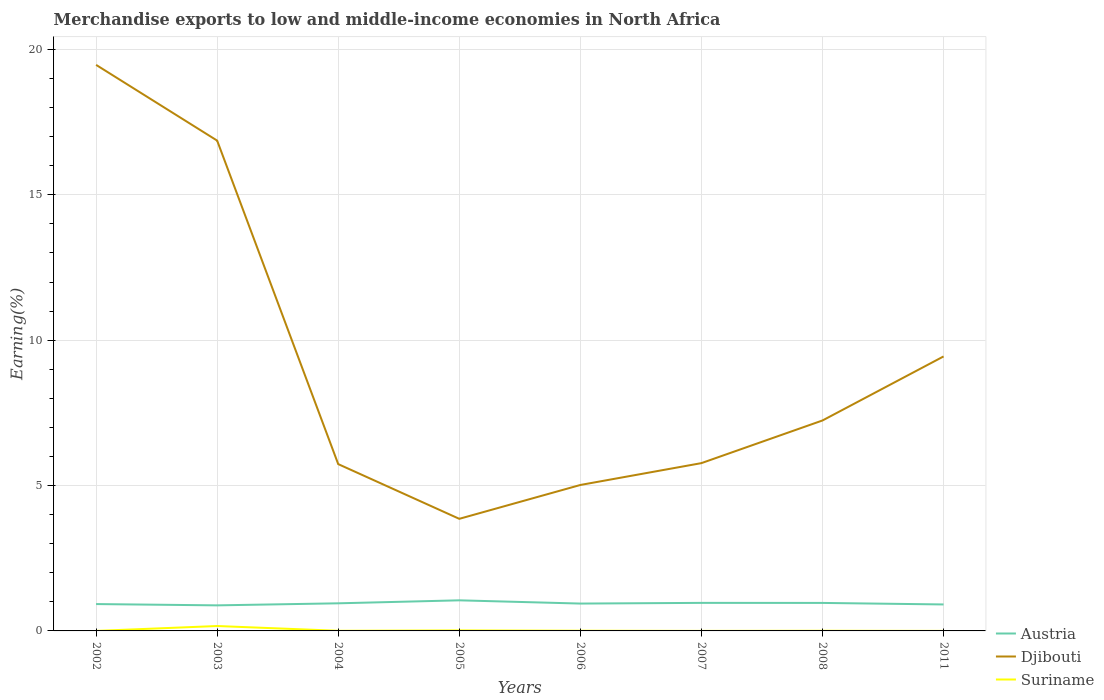Does the line corresponding to Suriname intersect with the line corresponding to Austria?
Provide a succinct answer. No. Across all years, what is the maximum percentage of amount earned from merchandise exports in Djibouti?
Offer a very short reply. 3.86. In which year was the percentage of amount earned from merchandise exports in Austria maximum?
Give a very brief answer. 2003. What is the total percentage of amount earned from merchandise exports in Austria in the graph?
Your answer should be compact. -0.01. What is the difference between the highest and the second highest percentage of amount earned from merchandise exports in Suriname?
Your response must be concise. 0.17. What is the difference between the highest and the lowest percentage of amount earned from merchandise exports in Djibouti?
Your answer should be compact. 3. Does the graph contain any zero values?
Keep it short and to the point. No. Where does the legend appear in the graph?
Offer a very short reply. Bottom right. How many legend labels are there?
Your answer should be very brief. 3. How are the legend labels stacked?
Ensure brevity in your answer.  Vertical. What is the title of the graph?
Ensure brevity in your answer.  Merchandise exports to low and middle-income economies in North Africa. What is the label or title of the X-axis?
Provide a succinct answer. Years. What is the label or title of the Y-axis?
Your answer should be compact. Earning(%). What is the Earning(%) in Austria in 2002?
Make the answer very short. 0.92. What is the Earning(%) of Djibouti in 2002?
Your response must be concise. 19.47. What is the Earning(%) in Suriname in 2002?
Provide a short and direct response. 0. What is the Earning(%) of Austria in 2003?
Give a very brief answer. 0.88. What is the Earning(%) in Djibouti in 2003?
Provide a short and direct response. 16.86. What is the Earning(%) of Suriname in 2003?
Your answer should be compact. 0.17. What is the Earning(%) in Austria in 2004?
Provide a short and direct response. 0.95. What is the Earning(%) in Djibouti in 2004?
Give a very brief answer. 5.74. What is the Earning(%) of Suriname in 2004?
Your response must be concise. 0. What is the Earning(%) of Austria in 2005?
Your response must be concise. 1.05. What is the Earning(%) in Djibouti in 2005?
Provide a succinct answer. 3.86. What is the Earning(%) in Suriname in 2005?
Ensure brevity in your answer.  0.02. What is the Earning(%) in Austria in 2006?
Offer a very short reply. 0.94. What is the Earning(%) of Djibouti in 2006?
Offer a terse response. 5.02. What is the Earning(%) of Suriname in 2006?
Your answer should be very brief. 0.01. What is the Earning(%) in Austria in 2007?
Provide a succinct answer. 0.96. What is the Earning(%) of Djibouti in 2007?
Ensure brevity in your answer.  5.77. What is the Earning(%) in Suriname in 2007?
Your answer should be very brief. 0. What is the Earning(%) in Austria in 2008?
Your answer should be very brief. 0.96. What is the Earning(%) of Djibouti in 2008?
Make the answer very short. 7.24. What is the Earning(%) of Suriname in 2008?
Your response must be concise. 0.01. What is the Earning(%) in Austria in 2011?
Provide a short and direct response. 0.91. What is the Earning(%) in Djibouti in 2011?
Ensure brevity in your answer.  9.44. What is the Earning(%) in Suriname in 2011?
Give a very brief answer. 0. Across all years, what is the maximum Earning(%) of Austria?
Ensure brevity in your answer.  1.05. Across all years, what is the maximum Earning(%) in Djibouti?
Your response must be concise. 19.47. Across all years, what is the maximum Earning(%) of Suriname?
Provide a succinct answer. 0.17. Across all years, what is the minimum Earning(%) in Austria?
Your response must be concise. 0.88. Across all years, what is the minimum Earning(%) of Djibouti?
Your answer should be compact. 3.86. Across all years, what is the minimum Earning(%) in Suriname?
Make the answer very short. 0. What is the total Earning(%) in Austria in the graph?
Your answer should be compact. 7.58. What is the total Earning(%) of Djibouti in the graph?
Make the answer very short. 73.39. What is the total Earning(%) of Suriname in the graph?
Ensure brevity in your answer.  0.21. What is the difference between the Earning(%) of Austria in 2002 and that in 2003?
Your answer should be very brief. 0.04. What is the difference between the Earning(%) of Djibouti in 2002 and that in 2003?
Make the answer very short. 2.6. What is the difference between the Earning(%) in Suriname in 2002 and that in 2003?
Your response must be concise. -0.17. What is the difference between the Earning(%) in Austria in 2002 and that in 2004?
Make the answer very short. -0.03. What is the difference between the Earning(%) in Djibouti in 2002 and that in 2004?
Provide a short and direct response. 13.73. What is the difference between the Earning(%) in Suriname in 2002 and that in 2004?
Offer a very short reply. -0. What is the difference between the Earning(%) in Austria in 2002 and that in 2005?
Offer a terse response. -0.13. What is the difference between the Earning(%) of Djibouti in 2002 and that in 2005?
Keep it short and to the point. 15.61. What is the difference between the Earning(%) of Suriname in 2002 and that in 2005?
Offer a terse response. -0.02. What is the difference between the Earning(%) of Austria in 2002 and that in 2006?
Your response must be concise. -0.02. What is the difference between the Earning(%) in Djibouti in 2002 and that in 2006?
Your answer should be very brief. 14.45. What is the difference between the Earning(%) in Suriname in 2002 and that in 2006?
Provide a succinct answer. -0.01. What is the difference between the Earning(%) of Austria in 2002 and that in 2007?
Provide a succinct answer. -0.04. What is the difference between the Earning(%) of Djibouti in 2002 and that in 2007?
Your response must be concise. 13.7. What is the difference between the Earning(%) of Suriname in 2002 and that in 2007?
Ensure brevity in your answer.  -0. What is the difference between the Earning(%) in Austria in 2002 and that in 2008?
Provide a short and direct response. -0.04. What is the difference between the Earning(%) in Djibouti in 2002 and that in 2008?
Ensure brevity in your answer.  12.23. What is the difference between the Earning(%) in Suriname in 2002 and that in 2008?
Your answer should be compact. -0.01. What is the difference between the Earning(%) of Austria in 2002 and that in 2011?
Offer a very short reply. 0.01. What is the difference between the Earning(%) of Djibouti in 2002 and that in 2011?
Your response must be concise. 10.03. What is the difference between the Earning(%) of Suriname in 2002 and that in 2011?
Provide a short and direct response. -0. What is the difference between the Earning(%) of Austria in 2003 and that in 2004?
Your answer should be very brief. -0.07. What is the difference between the Earning(%) of Djibouti in 2003 and that in 2004?
Your answer should be compact. 11.13. What is the difference between the Earning(%) in Suriname in 2003 and that in 2004?
Your response must be concise. 0.16. What is the difference between the Earning(%) in Austria in 2003 and that in 2005?
Your response must be concise. -0.17. What is the difference between the Earning(%) of Djibouti in 2003 and that in 2005?
Keep it short and to the point. 13.01. What is the difference between the Earning(%) in Suriname in 2003 and that in 2005?
Provide a succinct answer. 0.15. What is the difference between the Earning(%) in Austria in 2003 and that in 2006?
Your answer should be compact. -0.06. What is the difference between the Earning(%) of Djibouti in 2003 and that in 2006?
Your answer should be compact. 11.84. What is the difference between the Earning(%) in Suriname in 2003 and that in 2006?
Make the answer very short. 0.16. What is the difference between the Earning(%) in Austria in 2003 and that in 2007?
Offer a very short reply. -0.09. What is the difference between the Earning(%) in Djibouti in 2003 and that in 2007?
Make the answer very short. 11.09. What is the difference between the Earning(%) of Suriname in 2003 and that in 2007?
Your answer should be compact. 0.17. What is the difference between the Earning(%) in Austria in 2003 and that in 2008?
Offer a very short reply. -0.08. What is the difference between the Earning(%) of Djibouti in 2003 and that in 2008?
Keep it short and to the point. 9.63. What is the difference between the Earning(%) in Suriname in 2003 and that in 2008?
Offer a very short reply. 0.16. What is the difference between the Earning(%) of Austria in 2003 and that in 2011?
Your response must be concise. -0.03. What is the difference between the Earning(%) of Djibouti in 2003 and that in 2011?
Make the answer very short. 7.42. What is the difference between the Earning(%) of Suriname in 2003 and that in 2011?
Provide a short and direct response. 0.17. What is the difference between the Earning(%) in Austria in 2004 and that in 2005?
Your response must be concise. -0.1. What is the difference between the Earning(%) in Djibouti in 2004 and that in 2005?
Provide a short and direct response. 1.88. What is the difference between the Earning(%) in Suriname in 2004 and that in 2005?
Provide a succinct answer. -0.01. What is the difference between the Earning(%) in Austria in 2004 and that in 2006?
Provide a short and direct response. 0.01. What is the difference between the Earning(%) in Djibouti in 2004 and that in 2006?
Offer a very short reply. 0.72. What is the difference between the Earning(%) of Suriname in 2004 and that in 2006?
Offer a very short reply. -0. What is the difference between the Earning(%) in Austria in 2004 and that in 2007?
Make the answer very short. -0.01. What is the difference between the Earning(%) in Djibouti in 2004 and that in 2007?
Your response must be concise. -0.03. What is the difference between the Earning(%) in Suriname in 2004 and that in 2007?
Your response must be concise. 0. What is the difference between the Earning(%) in Austria in 2004 and that in 2008?
Keep it short and to the point. -0.01. What is the difference between the Earning(%) in Djibouti in 2004 and that in 2008?
Give a very brief answer. -1.5. What is the difference between the Earning(%) in Suriname in 2004 and that in 2008?
Make the answer very short. -0. What is the difference between the Earning(%) of Austria in 2004 and that in 2011?
Provide a short and direct response. 0.04. What is the difference between the Earning(%) in Djibouti in 2004 and that in 2011?
Keep it short and to the point. -3.7. What is the difference between the Earning(%) of Suriname in 2004 and that in 2011?
Make the answer very short. 0. What is the difference between the Earning(%) in Djibouti in 2005 and that in 2006?
Give a very brief answer. -1.16. What is the difference between the Earning(%) in Suriname in 2005 and that in 2006?
Offer a terse response. 0.01. What is the difference between the Earning(%) of Austria in 2005 and that in 2007?
Offer a very short reply. 0.09. What is the difference between the Earning(%) of Djibouti in 2005 and that in 2007?
Provide a succinct answer. -1.92. What is the difference between the Earning(%) of Suriname in 2005 and that in 2007?
Provide a succinct answer. 0.02. What is the difference between the Earning(%) of Austria in 2005 and that in 2008?
Keep it short and to the point. 0.09. What is the difference between the Earning(%) in Djibouti in 2005 and that in 2008?
Give a very brief answer. -3.38. What is the difference between the Earning(%) in Suriname in 2005 and that in 2008?
Ensure brevity in your answer.  0.01. What is the difference between the Earning(%) of Austria in 2005 and that in 2011?
Provide a succinct answer. 0.14. What is the difference between the Earning(%) in Djibouti in 2005 and that in 2011?
Your answer should be very brief. -5.58. What is the difference between the Earning(%) in Suriname in 2005 and that in 2011?
Your response must be concise. 0.02. What is the difference between the Earning(%) of Austria in 2006 and that in 2007?
Ensure brevity in your answer.  -0.02. What is the difference between the Earning(%) in Djibouti in 2006 and that in 2007?
Ensure brevity in your answer.  -0.75. What is the difference between the Earning(%) of Suriname in 2006 and that in 2007?
Your answer should be compact. 0.01. What is the difference between the Earning(%) in Austria in 2006 and that in 2008?
Provide a succinct answer. -0.02. What is the difference between the Earning(%) in Djibouti in 2006 and that in 2008?
Your answer should be very brief. -2.22. What is the difference between the Earning(%) in Suriname in 2006 and that in 2008?
Keep it short and to the point. 0. What is the difference between the Earning(%) of Austria in 2006 and that in 2011?
Your answer should be compact. 0.03. What is the difference between the Earning(%) in Djibouti in 2006 and that in 2011?
Offer a very short reply. -4.42. What is the difference between the Earning(%) in Suriname in 2006 and that in 2011?
Make the answer very short. 0.01. What is the difference between the Earning(%) of Austria in 2007 and that in 2008?
Keep it short and to the point. 0. What is the difference between the Earning(%) of Djibouti in 2007 and that in 2008?
Your answer should be very brief. -1.47. What is the difference between the Earning(%) of Suriname in 2007 and that in 2008?
Give a very brief answer. -0. What is the difference between the Earning(%) in Austria in 2007 and that in 2011?
Make the answer very short. 0.05. What is the difference between the Earning(%) in Djibouti in 2007 and that in 2011?
Give a very brief answer. -3.67. What is the difference between the Earning(%) of Suriname in 2007 and that in 2011?
Keep it short and to the point. -0. What is the difference between the Earning(%) in Austria in 2008 and that in 2011?
Give a very brief answer. 0.05. What is the difference between the Earning(%) of Djibouti in 2008 and that in 2011?
Keep it short and to the point. -2.2. What is the difference between the Earning(%) of Suriname in 2008 and that in 2011?
Offer a very short reply. 0. What is the difference between the Earning(%) of Austria in 2002 and the Earning(%) of Djibouti in 2003?
Give a very brief answer. -15.94. What is the difference between the Earning(%) of Austria in 2002 and the Earning(%) of Suriname in 2003?
Your answer should be very brief. 0.75. What is the difference between the Earning(%) of Djibouti in 2002 and the Earning(%) of Suriname in 2003?
Offer a terse response. 19.3. What is the difference between the Earning(%) in Austria in 2002 and the Earning(%) in Djibouti in 2004?
Your answer should be compact. -4.81. What is the difference between the Earning(%) of Austria in 2002 and the Earning(%) of Suriname in 2004?
Give a very brief answer. 0.92. What is the difference between the Earning(%) of Djibouti in 2002 and the Earning(%) of Suriname in 2004?
Keep it short and to the point. 19.46. What is the difference between the Earning(%) of Austria in 2002 and the Earning(%) of Djibouti in 2005?
Your answer should be very brief. -2.93. What is the difference between the Earning(%) of Austria in 2002 and the Earning(%) of Suriname in 2005?
Make the answer very short. 0.91. What is the difference between the Earning(%) in Djibouti in 2002 and the Earning(%) in Suriname in 2005?
Offer a terse response. 19.45. What is the difference between the Earning(%) in Austria in 2002 and the Earning(%) in Djibouti in 2006?
Offer a terse response. -4.1. What is the difference between the Earning(%) of Austria in 2002 and the Earning(%) of Suriname in 2006?
Keep it short and to the point. 0.92. What is the difference between the Earning(%) in Djibouti in 2002 and the Earning(%) in Suriname in 2006?
Your answer should be compact. 19.46. What is the difference between the Earning(%) of Austria in 2002 and the Earning(%) of Djibouti in 2007?
Offer a very short reply. -4.85. What is the difference between the Earning(%) of Austria in 2002 and the Earning(%) of Suriname in 2007?
Provide a succinct answer. 0.92. What is the difference between the Earning(%) in Djibouti in 2002 and the Earning(%) in Suriname in 2007?
Provide a succinct answer. 19.47. What is the difference between the Earning(%) of Austria in 2002 and the Earning(%) of Djibouti in 2008?
Your answer should be very brief. -6.31. What is the difference between the Earning(%) of Austria in 2002 and the Earning(%) of Suriname in 2008?
Offer a terse response. 0.92. What is the difference between the Earning(%) in Djibouti in 2002 and the Earning(%) in Suriname in 2008?
Keep it short and to the point. 19.46. What is the difference between the Earning(%) of Austria in 2002 and the Earning(%) of Djibouti in 2011?
Ensure brevity in your answer.  -8.52. What is the difference between the Earning(%) in Austria in 2002 and the Earning(%) in Suriname in 2011?
Your answer should be compact. 0.92. What is the difference between the Earning(%) in Djibouti in 2002 and the Earning(%) in Suriname in 2011?
Provide a short and direct response. 19.47. What is the difference between the Earning(%) in Austria in 2003 and the Earning(%) in Djibouti in 2004?
Make the answer very short. -4.86. What is the difference between the Earning(%) of Austria in 2003 and the Earning(%) of Suriname in 2004?
Offer a very short reply. 0.87. What is the difference between the Earning(%) in Djibouti in 2003 and the Earning(%) in Suriname in 2004?
Provide a succinct answer. 16.86. What is the difference between the Earning(%) of Austria in 2003 and the Earning(%) of Djibouti in 2005?
Make the answer very short. -2.98. What is the difference between the Earning(%) of Austria in 2003 and the Earning(%) of Suriname in 2005?
Ensure brevity in your answer.  0.86. What is the difference between the Earning(%) of Djibouti in 2003 and the Earning(%) of Suriname in 2005?
Ensure brevity in your answer.  16.85. What is the difference between the Earning(%) of Austria in 2003 and the Earning(%) of Djibouti in 2006?
Offer a terse response. -4.14. What is the difference between the Earning(%) of Austria in 2003 and the Earning(%) of Suriname in 2006?
Give a very brief answer. 0.87. What is the difference between the Earning(%) of Djibouti in 2003 and the Earning(%) of Suriname in 2006?
Your response must be concise. 16.86. What is the difference between the Earning(%) of Austria in 2003 and the Earning(%) of Djibouti in 2007?
Provide a succinct answer. -4.89. What is the difference between the Earning(%) of Austria in 2003 and the Earning(%) of Suriname in 2007?
Keep it short and to the point. 0.88. What is the difference between the Earning(%) of Djibouti in 2003 and the Earning(%) of Suriname in 2007?
Offer a terse response. 16.86. What is the difference between the Earning(%) in Austria in 2003 and the Earning(%) in Djibouti in 2008?
Your answer should be very brief. -6.36. What is the difference between the Earning(%) in Austria in 2003 and the Earning(%) in Suriname in 2008?
Provide a succinct answer. 0.87. What is the difference between the Earning(%) in Djibouti in 2003 and the Earning(%) in Suriname in 2008?
Offer a terse response. 16.86. What is the difference between the Earning(%) of Austria in 2003 and the Earning(%) of Djibouti in 2011?
Your answer should be very brief. -8.56. What is the difference between the Earning(%) in Austria in 2003 and the Earning(%) in Suriname in 2011?
Your response must be concise. 0.88. What is the difference between the Earning(%) in Djibouti in 2003 and the Earning(%) in Suriname in 2011?
Your response must be concise. 16.86. What is the difference between the Earning(%) in Austria in 2004 and the Earning(%) in Djibouti in 2005?
Offer a terse response. -2.91. What is the difference between the Earning(%) of Austria in 2004 and the Earning(%) of Suriname in 2005?
Offer a terse response. 0.93. What is the difference between the Earning(%) in Djibouti in 2004 and the Earning(%) in Suriname in 2005?
Give a very brief answer. 5.72. What is the difference between the Earning(%) in Austria in 2004 and the Earning(%) in Djibouti in 2006?
Give a very brief answer. -4.07. What is the difference between the Earning(%) in Austria in 2004 and the Earning(%) in Suriname in 2006?
Offer a terse response. 0.94. What is the difference between the Earning(%) in Djibouti in 2004 and the Earning(%) in Suriname in 2006?
Provide a short and direct response. 5.73. What is the difference between the Earning(%) of Austria in 2004 and the Earning(%) of Djibouti in 2007?
Provide a short and direct response. -4.82. What is the difference between the Earning(%) in Austria in 2004 and the Earning(%) in Suriname in 2007?
Offer a very short reply. 0.95. What is the difference between the Earning(%) in Djibouti in 2004 and the Earning(%) in Suriname in 2007?
Offer a terse response. 5.74. What is the difference between the Earning(%) in Austria in 2004 and the Earning(%) in Djibouti in 2008?
Make the answer very short. -6.29. What is the difference between the Earning(%) of Austria in 2004 and the Earning(%) of Suriname in 2008?
Make the answer very short. 0.94. What is the difference between the Earning(%) of Djibouti in 2004 and the Earning(%) of Suriname in 2008?
Provide a succinct answer. 5.73. What is the difference between the Earning(%) of Austria in 2004 and the Earning(%) of Djibouti in 2011?
Offer a very short reply. -8.49. What is the difference between the Earning(%) in Austria in 2004 and the Earning(%) in Suriname in 2011?
Offer a terse response. 0.95. What is the difference between the Earning(%) of Djibouti in 2004 and the Earning(%) of Suriname in 2011?
Provide a short and direct response. 5.74. What is the difference between the Earning(%) of Austria in 2005 and the Earning(%) of Djibouti in 2006?
Your answer should be compact. -3.97. What is the difference between the Earning(%) of Austria in 2005 and the Earning(%) of Suriname in 2006?
Provide a succinct answer. 1.05. What is the difference between the Earning(%) of Djibouti in 2005 and the Earning(%) of Suriname in 2006?
Your answer should be compact. 3.85. What is the difference between the Earning(%) in Austria in 2005 and the Earning(%) in Djibouti in 2007?
Ensure brevity in your answer.  -4.72. What is the difference between the Earning(%) of Austria in 2005 and the Earning(%) of Suriname in 2007?
Provide a short and direct response. 1.05. What is the difference between the Earning(%) in Djibouti in 2005 and the Earning(%) in Suriname in 2007?
Give a very brief answer. 3.85. What is the difference between the Earning(%) of Austria in 2005 and the Earning(%) of Djibouti in 2008?
Keep it short and to the point. -6.19. What is the difference between the Earning(%) of Austria in 2005 and the Earning(%) of Suriname in 2008?
Your response must be concise. 1.05. What is the difference between the Earning(%) of Djibouti in 2005 and the Earning(%) of Suriname in 2008?
Keep it short and to the point. 3.85. What is the difference between the Earning(%) of Austria in 2005 and the Earning(%) of Djibouti in 2011?
Provide a short and direct response. -8.39. What is the difference between the Earning(%) of Austria in 2005 and the Earning(%) of Suriname in 2011?
Offer a terse response. 1.05. What is the difference between the Earning(%) in Djibouti in 2005 and the Earning(%) in Suriname in 2011?
Provide a succinct answer. 3.85. What is the difference between the Earning(%) of Austria in 2006 and the Earning(%) of Djibouti in 2007?
Ensure brevity in your answer.  -4.83. What is the difference between the Earning(%) in Austria in 2006 and the Earning(%) in Suriname in 2007?
Provide a succinct answer. 0.94. What is the difference between the Earning(%) of Djibouti in 2006 and the Earning(%) of Suriname in 2007?
Offer a very short reply. 5.02. What is the difference between the Earning(%) in Austria in 2006 and the Earning(%) in Djibouti in 2008?
Keep it short and to the point. -6.3. What is the difference between the Earning(%) in Austria in 2006 and the Earning(%) in Suriname in 2008?
Give a very brief answer. 0.94. What is the difference between the Earning(%) in Djibouti in 2006 and the Earning(%) in Suriname in 2008?
Provide a short and direct response. 5.01. What is the difference between the Earning(%) in Austria in 2006 and the Earning(%) in Djibouti in 2011?
Provide a succinct answer. -8.5. What is the difference between the Earning(%) in Austria in 2006 and the Earning(%) in Suriname in 2011?
Your answer should be very brief. 0.94. What is the difference between the Earning(%) of Djibouti in 2006 and the Earning(%) of Suriname in 2011?
Provide a succinct answer. 5.02. What is the difference between the Earning(%) of Austria in 2007 and the Earning(%) of Djibouti in 2008?
Offer a very short reply. -6.27. What is the difference between the Earning(%) in Austria in 2007 and the Earning(%) in Suriname in 2008?
Ensure brevity in your answer.  0.96. What is the difference between the Earning(%) in Djibouti in 2007 and the Earning(%) in Suriname in 2008?
Ensure brevity in your answer.  5.77. What is the difference between the Earning(%) in Austria in 2007 and the Earning(%) in Djibouti in 2011?
Your answer should be compact. -8.48. What is the difference between the Earning(%) of Austria in 2007 and the Earning(%) of Suriname in 2011?
Offer a terse response. 0.96. What is the difference between the Earning(%) in Djibouti in 2007 and the Earning(%) in Suriname in 2011?
Offer a terse response. 5.77. What is the difference between the Earning(%) in Austria in 2008 and the Earning(%) in Djibouti in 2011?
Your answer should be compact. -8.48. What is the difference between the Earning(%) in Austria in 2008 and the Earning(%) in Suriname in 2011?
Your response must be concise. 0.96. What is the difference between the Earning(%) of Djibouti in 2008 and the Earning(%) of Suriname in 2011?
Your answer should be very brief. 7.24. What is the average Earning(%) of Austria per year?
Give a very brief answer. 0.95. What is the average Earning(%) in Djibouti per year?
Provide a short and direct response. 9.17. What is the average Earning(%) in Suriname per year?
Offer a terse response. 0.03. In the year 2002, what is the difference between the Earning(%) of Austria and Earning(%) of Djibouti?
Your answer should be very brief. -18.54. In the year 2002, what is the difference between the Earning(%) in Austria and Earning(%) in Suriname?
Give a very brief answer. 0.92. In the year 2002, what is the difference between the Earning(%) in Djibouti and Earning(%) in Suriname?
Your response must be concise. 19.47. In the year 2003, what is the difference between the Earning(%) of Austria and Earning(%) of Djibouti?
Ensure brevity in your answer.  -15.98. In the year 2003, what is the difference between the Earning(%) of Austria and Earning(%) of Suriname?
Your answer should be compact. 0.71. In the year 2003, what is the difference between the Earning(%) of Djibouti and Earning(%) of Suriname?
Your answer should be compact. 16.69. In the year 2004, what is the difference between the Earning(%) in Austria and Earning(%) in Djibouti?
Offer a terse response. -4.79. In the year 2004, what is the difference between the Earning(%) in Austria and Earning(%) in Suriname?
Your answer should be compact. 0.94. In the year 2004, what is the difference between the Earning(%) of Djibouti and Earning(%) of Suriname?
Give a very brief answer. 5.73. In the year 2005, what is the difference between the Earning(%) of Austria and Earning(%) of Djibouti?
Offer a terse response. -2.8. In the year 2005, what is the difference between the Earning(%) of Austria and Earning(%) of Suriname?
Offer a very short reply. 1.04. In the year 2005, what is the difference between the Earning(%) of Djibouti and Earning(%) of Suriname?
Offer a terse response. 3.84. In the year 2006, what is the difference between the Earning(%) of Austria and Earning(%) of Djibouti?
Give a very brief answer. -4.08. In the year 2006, what is the difference between the Earning(%) of Austria and Earning(%) of Suriname?
Offer a very short reply. 0.93. In the year 2006, what is the difference between the Earning(%) of Djibouti and Earning(%) of Suriname?
Offer a very short reply. 5.01. In the year 2007, what is the difference between the Earning(%) in Austria and Earning(%) in Djibouti?
Provide a short and direct response. -4.81. In the year 2007, what is the difference between the Earning(%) in Austria and Earning(%) in Suriname?
Your answer should be very brief. 0.96. In the year 2007, what is the difference between the Earning(%) of Djibouti and Earning(%) of Suriname?
Provide a short and direct response. 5.77. In the year 2008, what is the difference between the Earning(%) in Austria and Earning(%) in Djibouti?
Give a very brief answer. -6.28. In the year 2008, what is the difference between the Earning(%) in Austria and Earning(%) in Suriname?
Ensure brevity in your answer.  0.96. In the year 2008, what is the difference between the Earning(%) in Djibouti and Earning(%) in Suriname?
Your answer should be compact. 7.23. In the year 2011, what is the difference between the Earning(%) in Austria and Earning(%) in Djibouti?
Offer a very short reply. -8.53. In the year 2011, what is the difference between the Earning(%) of Austria and Earning(%) of Suriname?
Provide a succinct answer. 0.91. In the year 2011, what is the difference between the Earning(%) of Djibouti and Earning(%) of Suriname?
Your response must be concise. 9.44. What is the ratio of the Earning(%) in Austria in 2002 to that in 2003?
Your response must be concise. 1.05. What is the ratio of the Earning(%) in Djibouti in 2002 to that in 2003?
Offer a terse response. 1.15. What is the ratio of the Earning(%) of Suriname in 2002 to that in 2003?
Offer a terse response. 0. What is the ratio of the Earning(%) of Austria in 2002 to that in 2004?
Offer a very short reply. 0.97. What is the ratio of the Earning(%) of Djibouti in 2002 to that in 2004?
Offer a very short reply. 3.39. What is the ratio of the Earning(%) in Suriname in 2002 to that in 2004?
Your answer should be compact. 0.06. What is the ratio of the Earning(%) in Austria in 2002 to that in 2005?
Your answer should be very brief. 0.88. What is the ratio of the Earning(%) of Djibouti in 2002 to that in 2005?
Give a very brief answer. 5.05. What is the ratio of the Earning(%) of Suriname in 2002 to that in 2005?
Provide a succinct answer. 0.02. What is the ratio of the Earning(%) of Austria in 2002 to that in 2006?
Keep it short and to the point. 0.98. What is the ratio of the Earning(%) in Djibouti in 2002 to that in 2006?
Offer a very short reply. 3.88. What is the ratio of the Earning(%) in Suriname in 2002 to that in 2006?
Your response must be concise. 0.04. What is the ratio of the Earning(%) of Austria in 2002 to that in 2007?
Keep it short and to the point. 0.96. What is the ratio of the Earning(%) of Djibouti in 2002 to that in 2007?
Provide a short and direct response. 3.37. What is the ratio of the Earning(%) in Suriname in 2002 to that in 2007?
Make the answer very short. 0.25. What is the ratio of the Earning(%) in Austria in 2002 to that in 2008?
Offer a very short reply. 0.96. What is the ratio of the Earning(%) of Djibouti in 2002 to that in 2008?
Your answer should be compact. 2.69. What is the ratio of the Earning(%) in Suriname in 2002 to that in 2008?
Your response must be concise. 0.05. What is the ratio of the Earning(%) of Austria in 2002 to that in 2011?
Give a very brief answer. 1.01. What is the ratio of the Earning(%) of Djibouti in 2002 to that in 2011?
Ensure brevity in your answer.  2.06. What is the ratio of the Earning(%) of Suriname in 2002 to that in 2011?
Keep it short and to the point. 0.23. What is the ratio of the Earning(%) in Austria in 2003 to that in 2004?
Your answer should be very brief. 0.93. What is the ratio of the Earning(%) in Djibouti in 2003 to that in 2004?
Provide a succinct answer. 2.94. What is the ratio of the Earning(%) in Suriname in 2003 to that in 2004?
Ensure brevity in your answer.  36.09. What is the ratio of the Earning(%) of Austria in 2003 to that in 2005?
Ensure brevity in your answer.  0.84. What is the ratio of the Earning(%) of Djibouti in 2003 to that in 2005?
Offer a very short reply. 4.37. What is the ratio of the Earning(%) in Suriname in 2003 to that in 2005?
Provide a short and direct response. 9.85. What is the ratio of the Earning(%) of Austria in 2003 to that in 2006?
Provide a short and direct response. 0.93. What is the ratio of the Earning(%) in Djibouti in 2003 to that in 2006?
Offer a terse response. 3.36. What is the ratio of the Earning(%) of Suriname in 2003 to that in 2006?
Your response must be concise. 23.88. What is the ratio of the Earning(%) in Austria in 2003 to that in 2007?
Your response must be concise. 0.91. What is the ratio of the Earning(%) of Djibouti in 2003 to that in 2007?
Your answer should be very brief. 2.92. What is the ratio of the Earning(%) in Suriname in 2003 to that in 2007?
Provide a succinct answer. 148.17. What is the ratio of the Earning(%) of Austria in 2003 to that in 2008?
Keep it short and to the point. 0.91. What is the ratio of the Earning(%) in Djibouti in 2003 to that in 2008?
Offer a very short reply. 2.33. What is the ratio of the Earning(%) of Suriname in 2003 to that in 2008?
Provide a short and direct response. 31.4. What is the ratio of the Earning(%) in Austria in 2003 to that in 2011?
Provide a succinct answer. 0.97. What is the ratio of the Earning(%) in Djibouti in 2003 to that in 2011?
Provide a short and direct response. 1.79. What is the ratio of the Earning(%) in Suriname in 2003 to that in 2011?
Offer a very short reply. 134.95. What is the ratio of the Earning(%) in Austria in 2004 to that in 2005?
Make the answer very short. 0.9. What is the ratio of the Earning(%) in Djibouti in 2004 to that in 2005?
Your answer should be compact. 1.49. What is the ratio of the Earning(%) in Suriname in 2004 to that in 2005?
Offer a very short reply. 0.27. What is the ratio of the Earning(%) in Austria in 2004 to that in 2006?
Offer a very short reply. 1.01. What is the ratio of the Earning(%) of Djibouti in 2004 to that in 2006?
Provide a succinct answer. 1.14. What is the ratio of the Earning(%) of Suriname in 2004 to that in 2006?
Keep it short and to the point. 0.66. What is the ratio of the Earning(%) in Austria in 2004 to that in 2007?
Your answer should be very brief. 0.98. What is the ratio of the Earning(%) of Suriname in 2004 to that in 2007?
Offer a very short reply. 4.11. What is the ratio of the Earning(%) of Austria in 2004 to that in 2008?
Your answer should be very brief. 0.99. What is the ratio of the Earning(%) of Djibouti in 2004 to that in 2008?
Provide a succinct answer. 0.79. What is the ratio of the Earning(%) in Suriname in 2004 to that in 2008?
Provide a succinct answer. 0.87. What is the ratio of the Earning(%) of Austria in 2004 to that in 2011?
Provide a succinct answer. 1.04. What is the ratio of the Earning(%) in Djibouti in 2004 to that in 2011?
Keep it short and to the point. 0.61. What is the ratio of the Earning(%) of Suriname in 2004 to that in 2011?
Give a very brief answer. 3.74. What is the ratio of the Earning(%) in Austria in 2005 to that in 2006?
Make the answer very short. 1.12. What is the ratio of the Earning(%) of Djibouti in 2005 to that in 2006?
Your answer should be very brief. 0.77. What is the ratio of the Earning(%) in Suriname in 2005 to that in 2006?
Keep it short and to the point. 2.43. What is the ratio of the Earning(%) of Austria in 2005 to that in 2007?
Keep it short and to the point. 1.09. What is the ratio of the Earning(%) in Djibouti in 2005 to that in 2007?
Ensure brevity in your answer.  0.67. What is the ratio of the Earning(%) in Suriname in 2005 to that in 2007?
Provide a short and direct response. 15.05. What is the ratio of the Earning(%) in Austria in 2005 to that in 2008?
Make the answer very short. 1.09. What is the ratio of the Earning(%) of Djibouti in 2005 to that in 2008?
Your response must be concise. 0.53. What is the ratio of the Earning(%) of Suriname in 2005 to that in 2008?
Keep it short and to the point. 3.19. What is the ratio of the Earning(%) of Austria in 2005 to that in 2011?
Provide a succinct answer. 1.16. What is the ratio of the Earning(%) of Djibouti in 2005 to that in 2011?
Provide a succinct answer. 0.41. What is the ratio of the Earning(%) in Suriname in 2005 to that in 2011?
Provide a short and direct response. 13.7. What is the ratio of the Earning(%) of Austria in 2006 to that in 2007?
Make the answer very short. 0.98. What is the ratio of the Earning(%) in Djibouti in 2006 to that in 2007?
Offer a very short reply. 0.87. What is the ratio of the Earning(%) in Suriname in 2006 to that in 2007?
Your answer should be compact. 6.2. What is the ratio of the Earning(%) of Austria in 2006 to that in 2008?
Provide a short and direct response. 0.98. What is the ratio of the Earning(%) of Djibouti in 2006 to that in 2008?
Provide a succinct answer. 0.69. What is the ratio of the Earning(%) in Suriname in 2006 to that in 2008?
Your answer should be compact. 1.32. What is the ratio of the Earning(%) in Austria in 2006 to that in 2011?
Provide a succinct answer. 1.03. What is the ratio of the Earning(%) of Djibouti in 2006 to that in 2011?
Offer a very short reply. 0.53. What is the ratio of the Earning(%) in Suriname in 2006 to that in 2011?
Your response must be concise. 5.65. What is the ratio of the Earning(%) in Djibouti in 2007 to that in 2008?
Make the answer very short. 0.8. What is the ratio of the Earning(%) in Suriname in 2007 to that in 2008?
Offer a very short reply. 0.21. What is the ratio of the Earning(%) of Austria in 2007 to that in 2011?
Give a very brief answer. 1.06. What is the ratio of the Earning(%) in Djibouti in 2007 to that in 2011?
Your response must be concise. 0.61. What is the ratio of the Earning(%) of Suriname in 2007 to that in 2011?
Provide a short and direct response. 0.91. What is the ratio of the Earning(%) of Austria in 2008 to that in 2011?
Keep it short and to the point. 1.06. What is the ratio of the Earning(%) in Djibouti in 2008 to that in 2011?
Give a very brief answer. 0.77. What is the ratio of the Earning(%) of Suriname in 2008 to that in 2011?
Make the answer very short. 4.3. What is the difference between the highest and the second highest Earning(%) of Austria?
Offer a very short reply. 0.09. What is the difference between the highest and the second highest Earning(%) in Djibouti?
Ensure brevity in your answer.  2.6. What is the difference between the highest and the second highest Earning(%) of Suriname?
Provide a short and direct response. 0.15. What is the difference between the highest and the lowest Earning(%) of Austria?
Your answer should be compact. 0.17. What is the difference between the highest and the lowest Earning(%) of Djibouti?
Your answer should be compact. 15.61. What is the difference between the highest and the lowest Earning(%) in Suriname?
Keep it short and to the point. 0.17. 